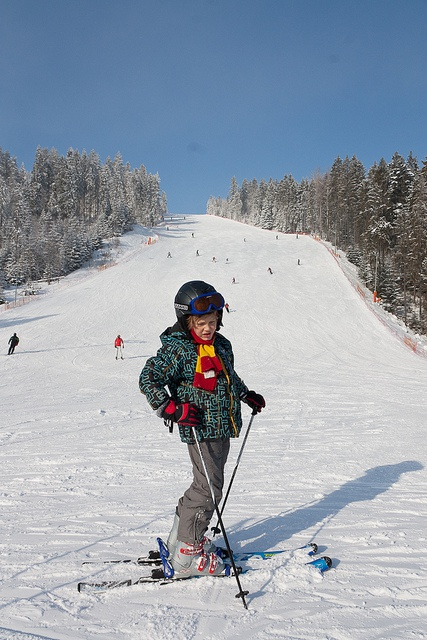Describe the objects in this image and their specific colors. I can see people in gray, black, darkgray, and teal tones, skis in gray, lightgray, darkgray, and black tones, people in gray, lightgray, and darkgray tones, people in gray, lightgray, darkgray, brown, and red tones, and people in gray, black, lightgray, and darkgray tones in this image. 